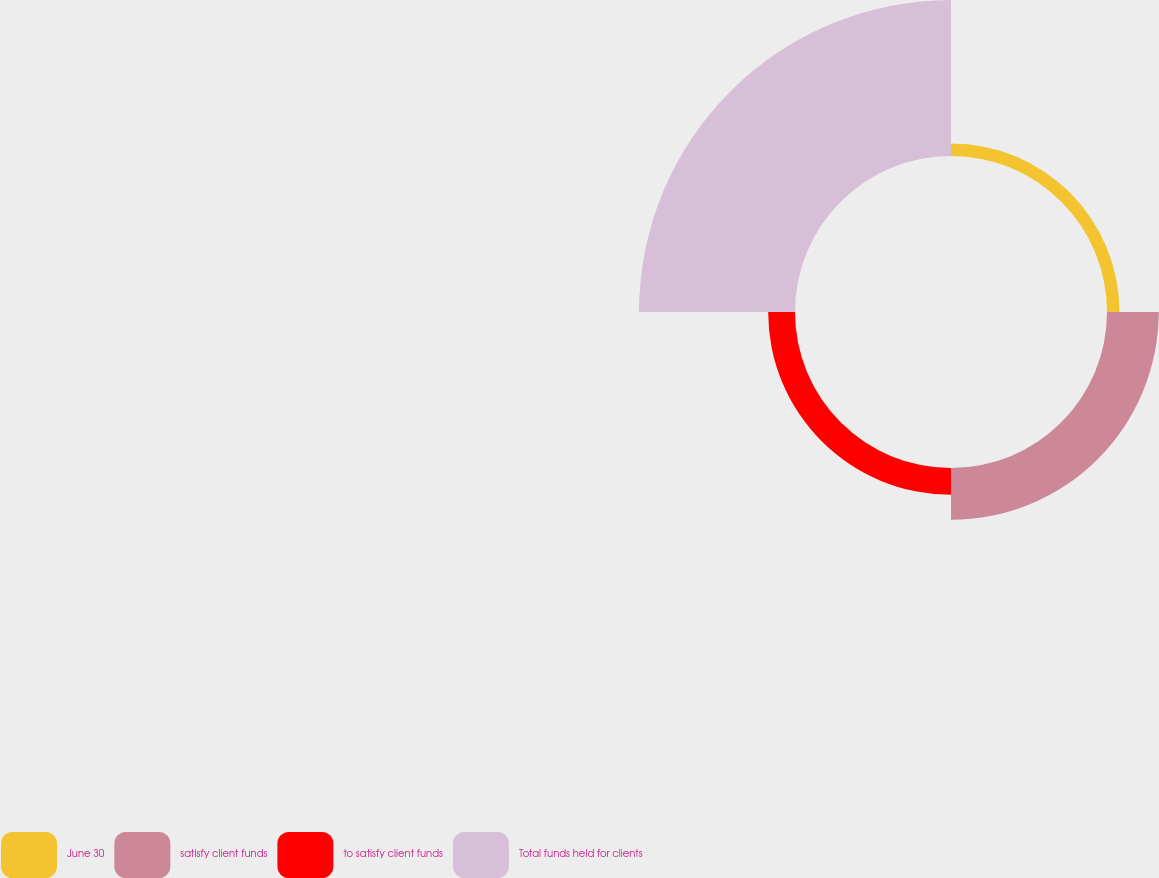Convert chart to OTSL. <chart><loc_0><loc_0><loc_500><loc_500><pie_chart><fcel>June 30<fcel>satisfy client funds<fcel>to satisfy client funds<fcel>Total funds held for clients<nl><fcel>5.05%<fcel>20.95%<fcel>10.86%<fcel>63.14%<nl></chart> 